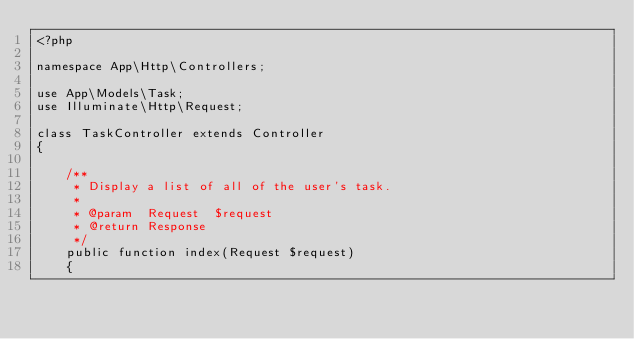<code> <loc_0><loc_0><loc_500><loc_500><_PHP_><?php

namespace App\Http\Controllers;

use App\Models\Task;
use Illuminate\Http\Request;

class TaskController extends Controller
{

    /**
     * Display a list of all of the user's task.
     *
     * @param  Request  $request
     * @return Response
     */
    public function index(Request $request)
    {</code> 